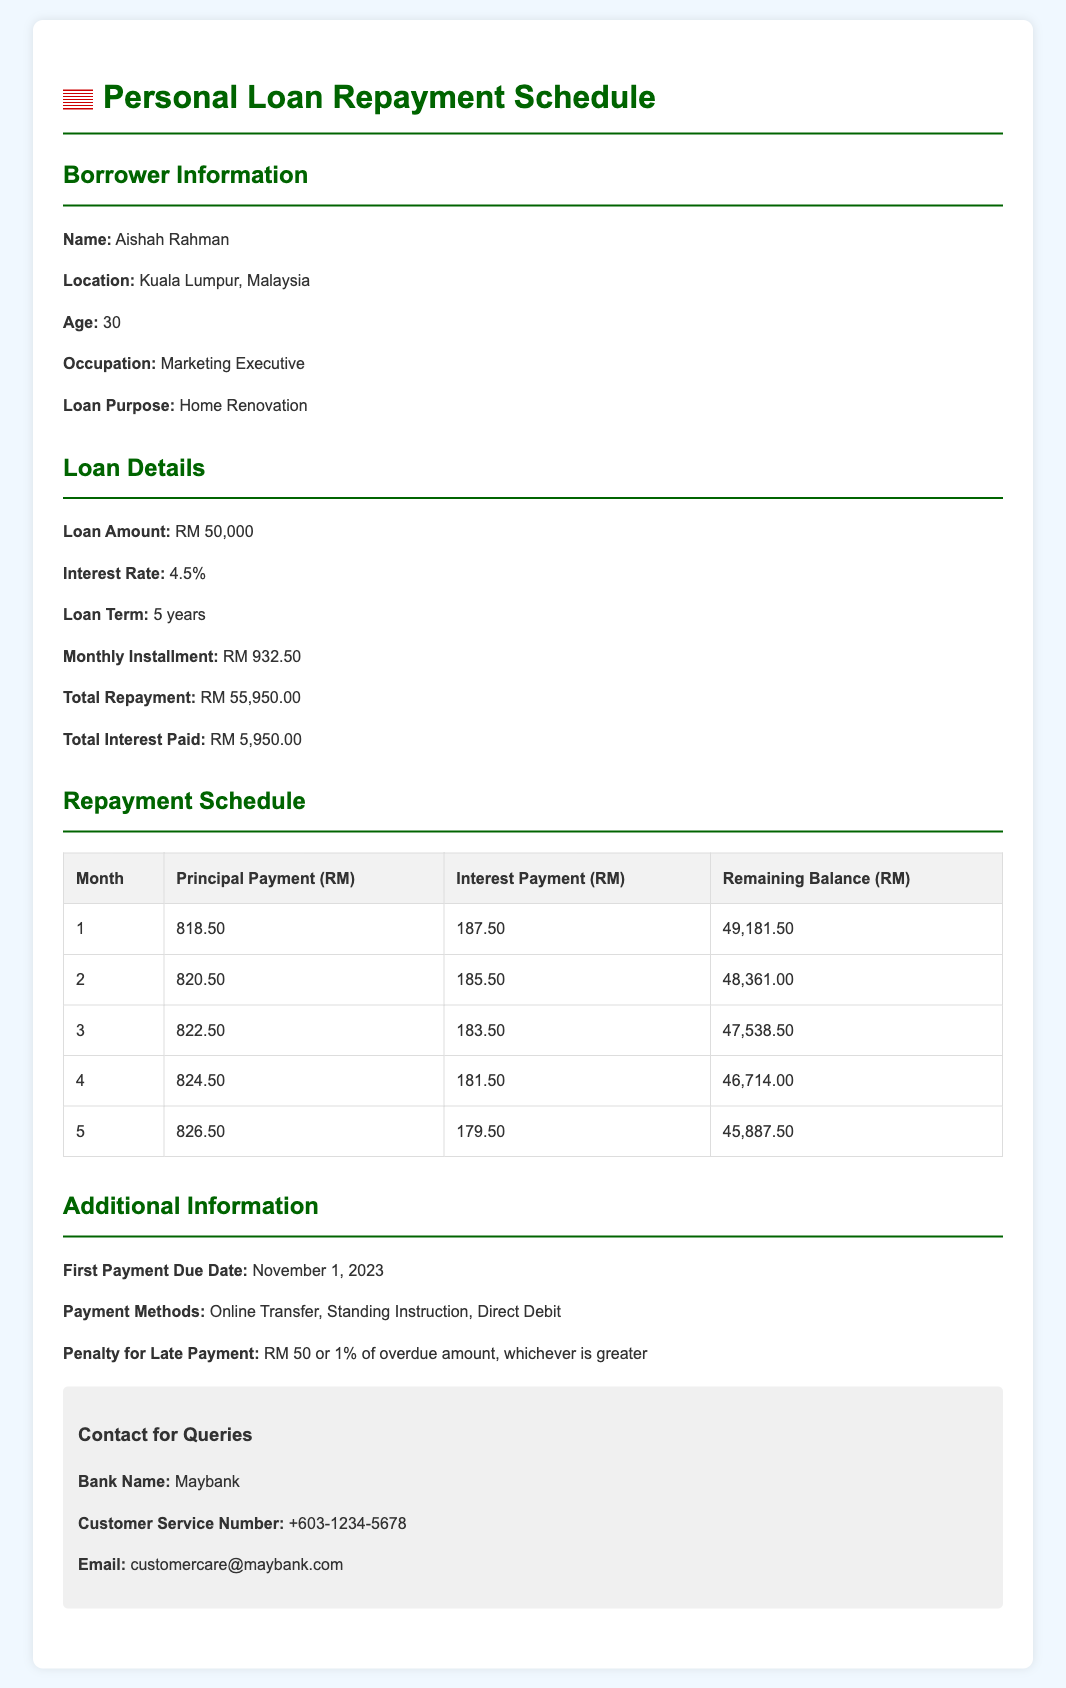What is the borrower's name? The borrower's name is provided in the document under borrower information.
Answer: Aishah Rahman What is the loan amount? The loan amount is specified in the loan details section of the document.
Answer: RM 50,000 What is the interest rate? The interest rate is mentioned in the loan details section, providing the rate applied to the loan.
Answer: 4.5% What is the monthly installment? The monthly installment is provided in the loan details and represents the amount to be paid each month.
Answer: RM 932.50 What is the total interest paid? The total interest paid is calculated and presented in the loan details section of the document.
Answer: RM 5,950.00 How much is the principal payment for the first month? The principal payment for the first month is detailed in the repayment schedule table of the document.
Answer: 818.50 What is the remaining balance after the second payment? The remaining balance after the second payment is found in the repayment schedule table.
Answer: RM 48,361.00 What is the penalty for late payment? The penalty for late payment is described in the additional information section of the document.
Answer: RM 50 or 1% of overdue amount When is the first payment due date? The first payment due date is mentioned in the additional information segment.
Answer: November 1, 2023 What is the loan purpose? The purpose for which the loan is taken is indicated under borrower information.
Answer: Home Renovation 